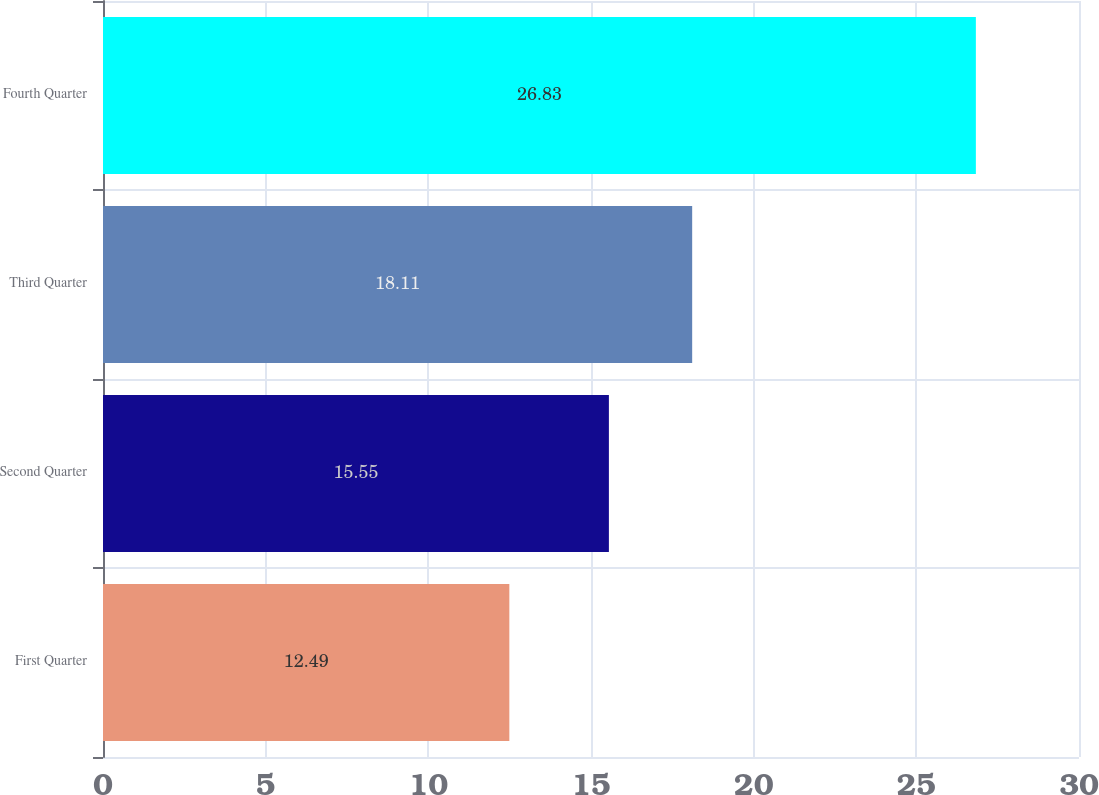<chart> <loc_0><loc_0><loc_500><loc_500><bar_chart><fcel>First Quarter<fcel>Second Quarter<fcel>Third Quarter<fcel>Fourth Quarter<nl><fcel>12.49<fcel>15.55<fcel>18.11<fcel>26.83<nl></chart> 